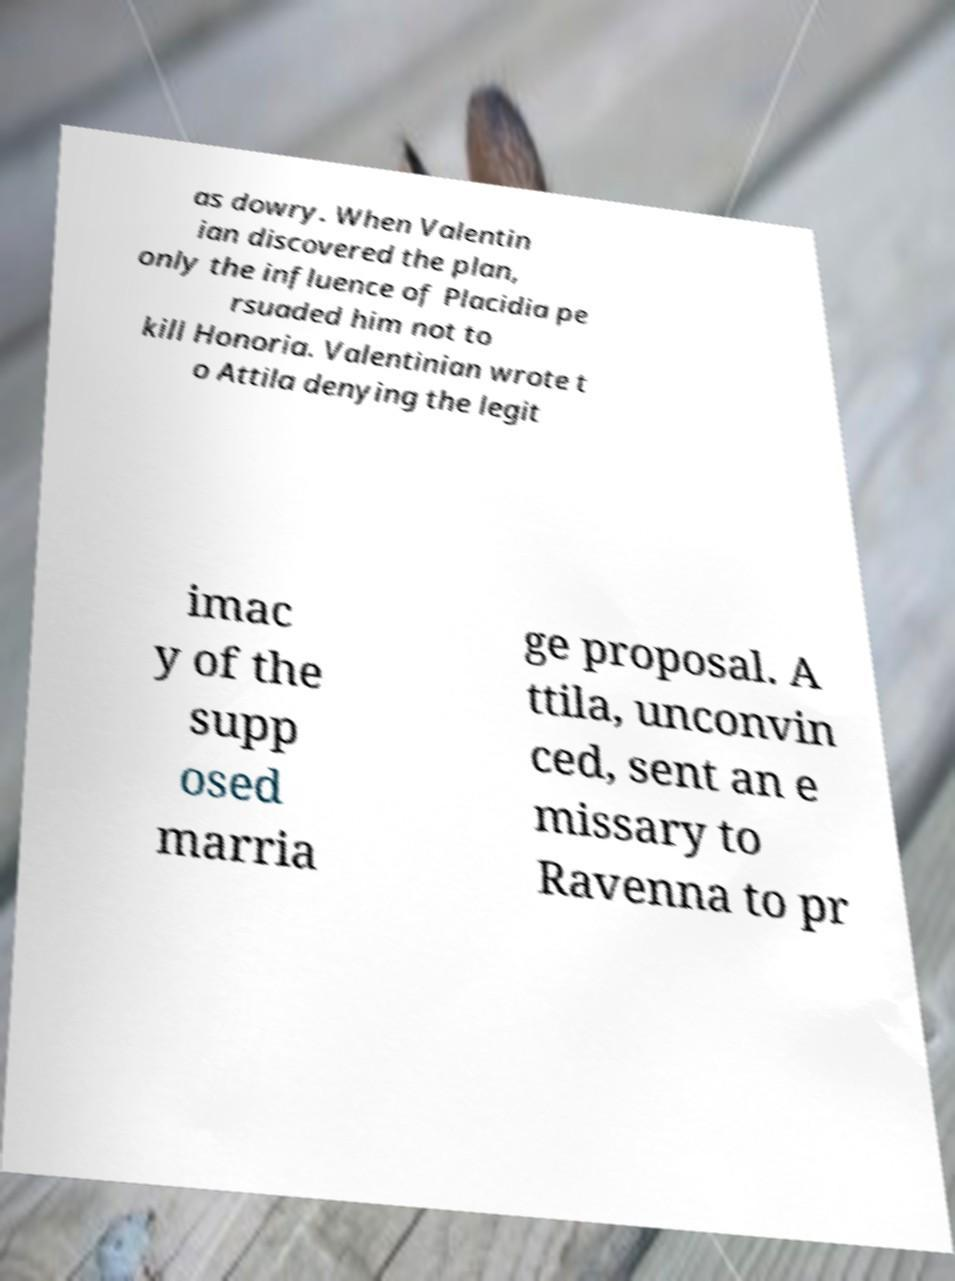I need the written content from this picture converted into text. Can you do that? as dowry. When Valentin ian discovered the plan, only the influence of Placidia pe rsuaded him not to kill Honoria. Valentinian wrote t o Attila denying the legit imac y of the supp osed marria ge proposal. A ttila, unconvin ced, sent an e missary to Ravenna to pr 